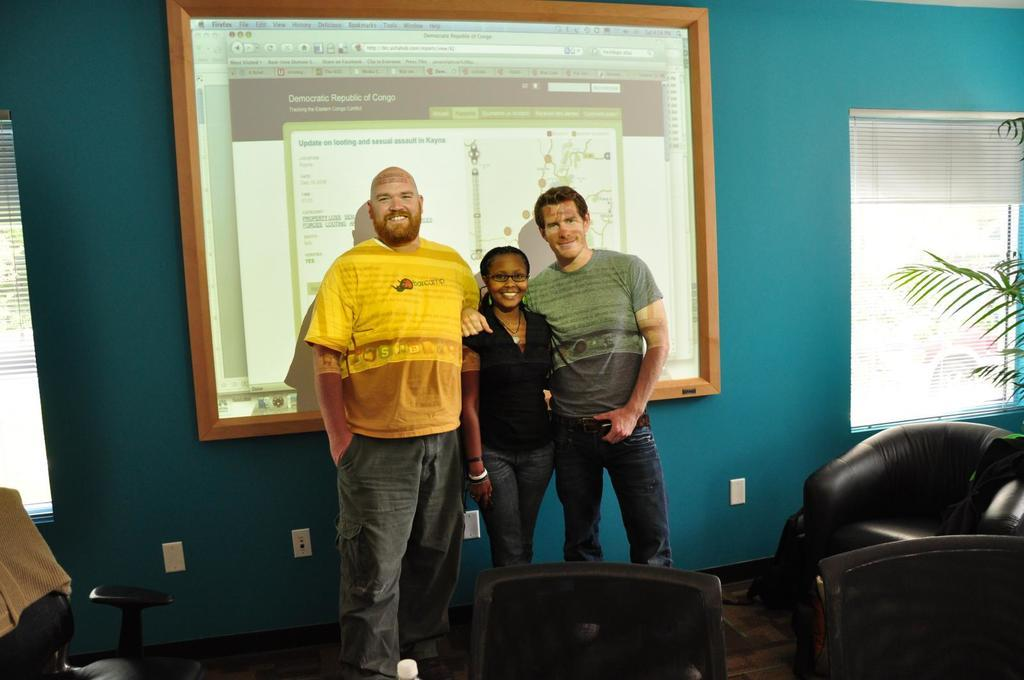How many people are in the image? There are three people standing and smiling in the image. What can be seen in the image besides the people? There are chairs, a plant, a screen, windows, window blinds, and a wall visible in the image. What is the condition of the floor in the image? The floor is visible in the image. What type of background elements are present in the image? There is a screen, windows, window blinds, and a wall in the background of the image. What type of rice is being cooked in the image? There is no rice present in the image; it features three people standing and smiling, chairs, a plant, a screen, windows, window blinds, and a wall. 